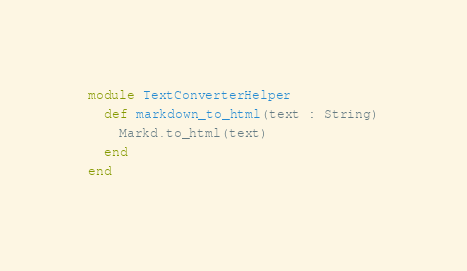<code> <loc_0><loc_0><loc_500><loc_500><_Crystal_>module TextConverterHelper
  def markdown_to_html(text : String)
    Markd.to_html(text)
  end
end
</code> 